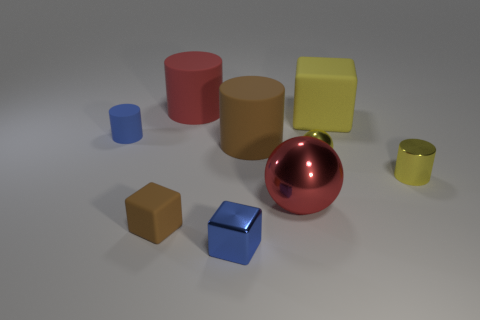Subtract all big cubes. How many cubes are left? 2 Subtract 2 cylinders. How many cylinders are left? 2 Add 1 small brown matte cylinders. How many objects exist? 10 Subtract all yellow cylinders. How many cylinders are left? 3 Subtract all purple cylinders. Subtract all gray cubes. How many cylinders are left? 4 Subtract all cylinders. How many objects are left? 5 Subtract 0 green balls. How many objects are left? 9 Subtract all tiny cylinders. Subtract all big red rubber objects. How many objects are left? 6 Add 4 balls. How many balls are left? 6 Add 2 large red metallic spheres. How many large red metallic spheres exist? 3 